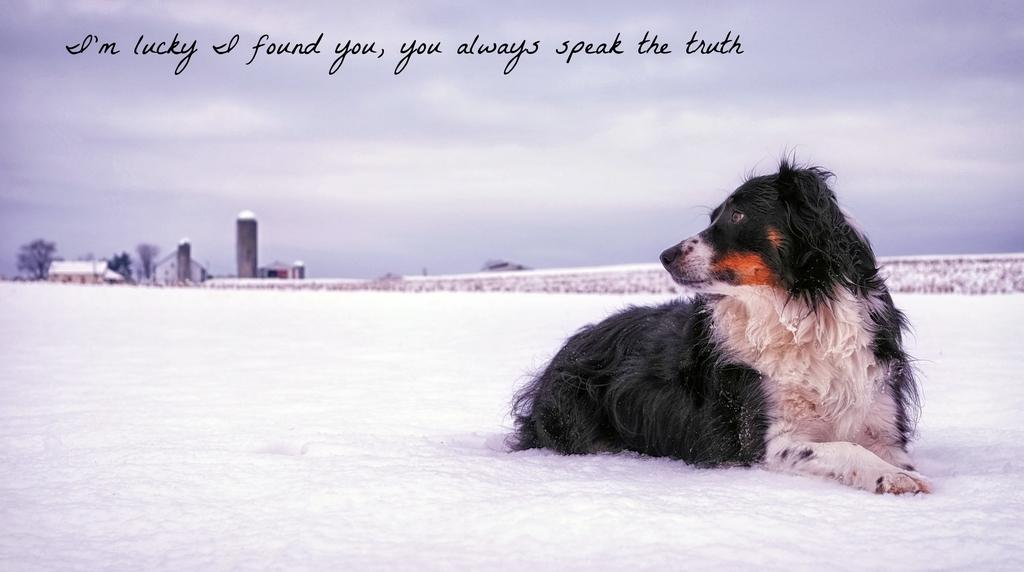What type of animal can be seen in the picture? There is a dog in the picture. What is the condition of the ground in the picture? There is snow on the ground. What structures are visible in the picture? There are buildings in the picture. What type of vegetation is present in the picture? There are trees in the picture. How would you describe the sky in the picture? The sky is cloudy. What is written at the top of the picture? There is text at the top of the picture. Can you tell me how many fans are visible in the picture? There are no fans present in the picture. Is there an agreement being signed in the picture? There is no agreement or signing activity depicted in the picture. 